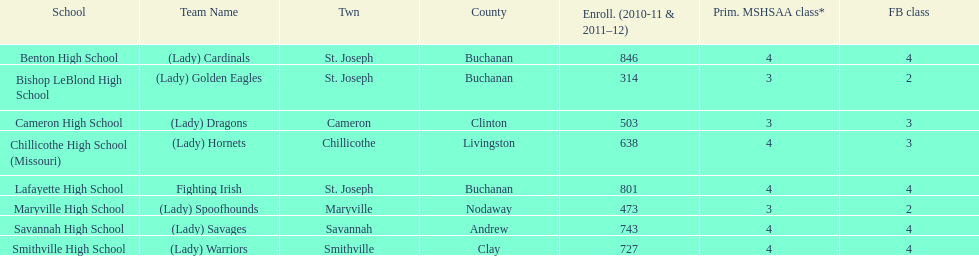Which school has the least amount of student enrollment between 2010-2011 and 2011-2012? Bishop LeBlond High School. 